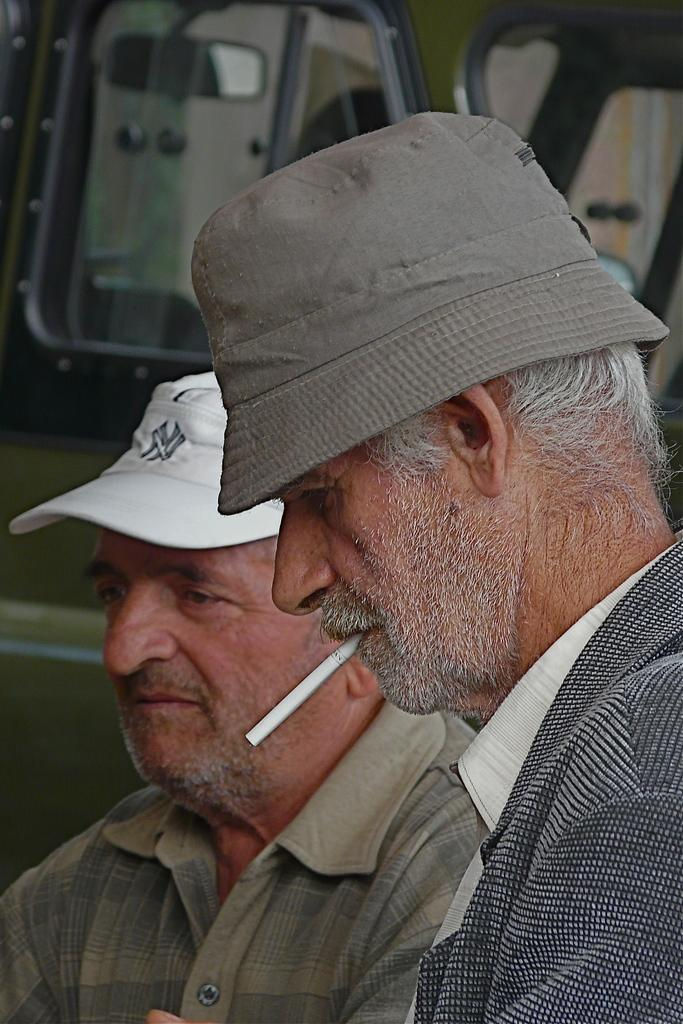How many people are in the image? There are two men in the image. What is one of the men doing in the image? One of the men is smoking a cigarette. What can be seen in the background of the image? There is a vehicle in the background of the image. What type of anger management techniques are the men discussing in the image? There is no indication in the image that the men are discussing anger management techniques. 